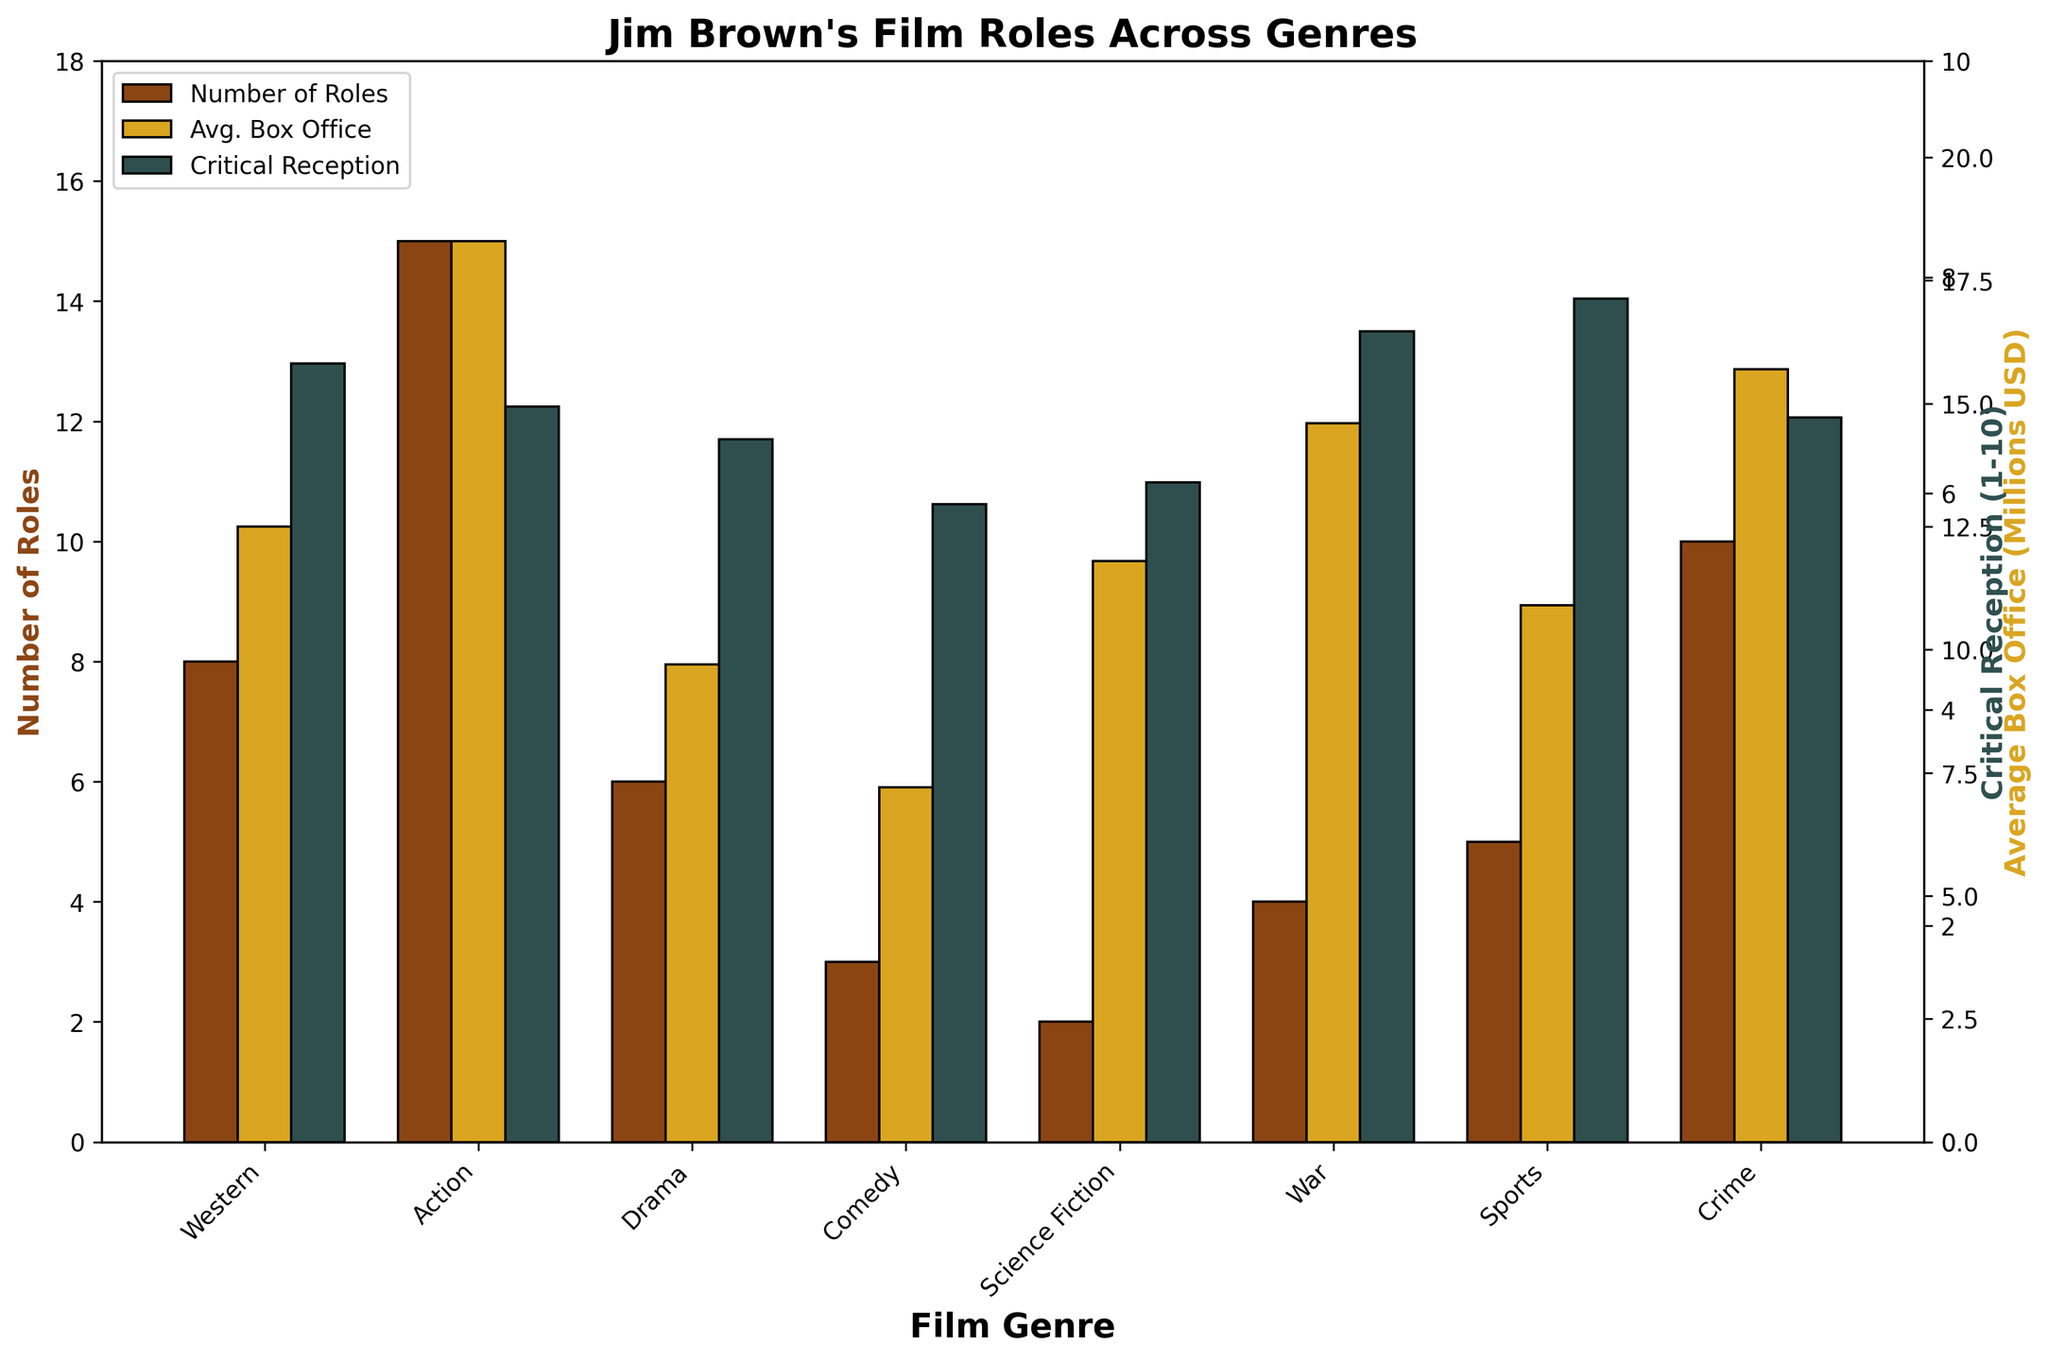What is the number of roles Jim Brown played in Western films compared to Science Fiction films? The number of roles in Western films is 8, and in Science Fiction films, he played 2 roles. Compared to Science Fiction, Jim Brown starred in 6 more Western films.
Answer: 6 more Western films Which genre had the highest average box office earnings among Jim Brown's films? From the figure, the bars representing 'Avg. Box Office' show that the Action genre has the highest average box office earnings.
Answer: Action How does the critical reception of Western films compare to that of War films? The critical reception for Western films is 7.2, while for War films it's 7.5. The War films have a slightly higher reception by 0.3.
Answer: War films received 0.3 higher What is the total number of roles Jim Brown had in Comedy and Sports films combined? Jim Brown played 3 roles in Comedy and 5 roles in Sports films. The total number of roles in these genres combined is 3 + 5 = 8.
Answer: 8 Which genres had a critical reception higher than 7? According to the figure, the genres with a critical reception higher than 7 are Western (7.2), War (7.5), and Sports (7.8).
Answer: Western, War, Sports Is the average box office for Drama films higher or lower than for Science Fiction films? The average box office for Drama films is 9.7 million USD, whereas for Science Fiction films it is 11.8 million USD. Therefore, Drama films have a lower average box office compared to Science Fiction films.
Answer: Lower What is the difference in the critical reception between Action and Drama films? The critical reception for Action films is 6.8, and for Drama films it is 6.5. The difference in reception is 0.3.
Answer: 0.3 In which genre did Jim Brown have the lowest number of roles, and what was the average box office for that genre? The genre with the lowest number of roles is Science Fiction, where he had 2 roles, and the average box office for Science Fiction films is 11.8 million USD.
Answer: Science Fiction, 11.8 million USD 